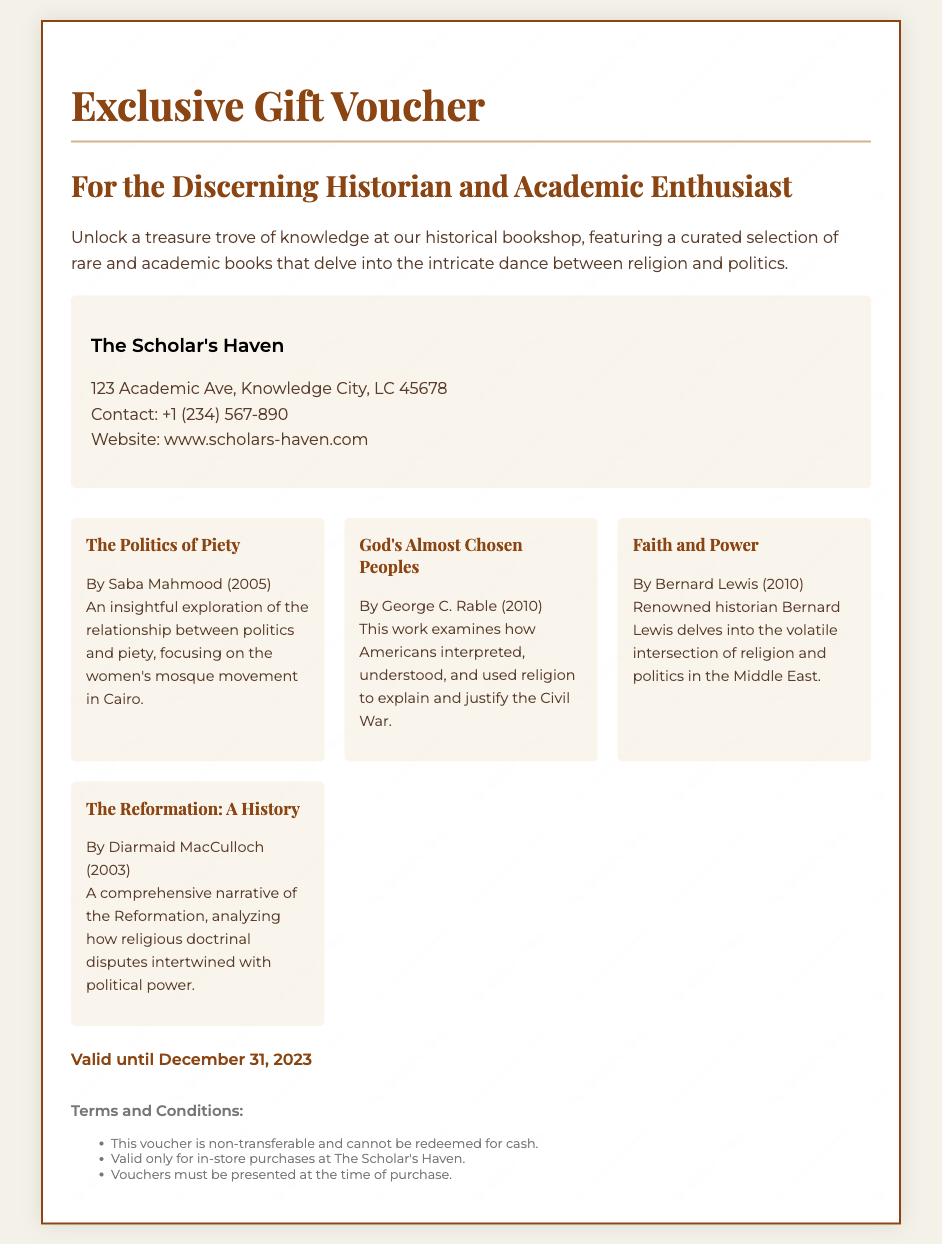What is the name of the bookshop? The document mentions the name of the bookshop, which is "The Scholar's Haven."
Answer: The Scholar's Haven What is the contact number for the bookshop? The document lists the contact number provided for the bookshop, which is +1 (234) 567-890.
Answer: +1 (234) 567-890 What is the expiration date of the voucher? The validity period of the voucher is stated in the document, which is until December 31, 2023.
Answer: December 31, 2023 Who is the author of "God's Almost Chosen Peoples"? The document includes information about the author of the book, which is George C. Rable.
Answer: George C. Rable What type of books does the voucher apply to? The document specifies that the voucher can be used for "rare and academic books" in the bookshop.
Answer: Rare and academic books Why might someone be interested in the voucher? The document highlights the focus on the interplay between religion and politics, which might attract historians and academics.
Answer: Interplay between religion and politics Is the voucher transferable? The terms state conditions regarding the voucher's transferability highlighted in the document which indicates that it is non-transferable.
Answer: Non-transferable What must be presented at the time of purchase? The terms mention that "vouchers must be presented at the time of purchase."
Answer: Vouchers 